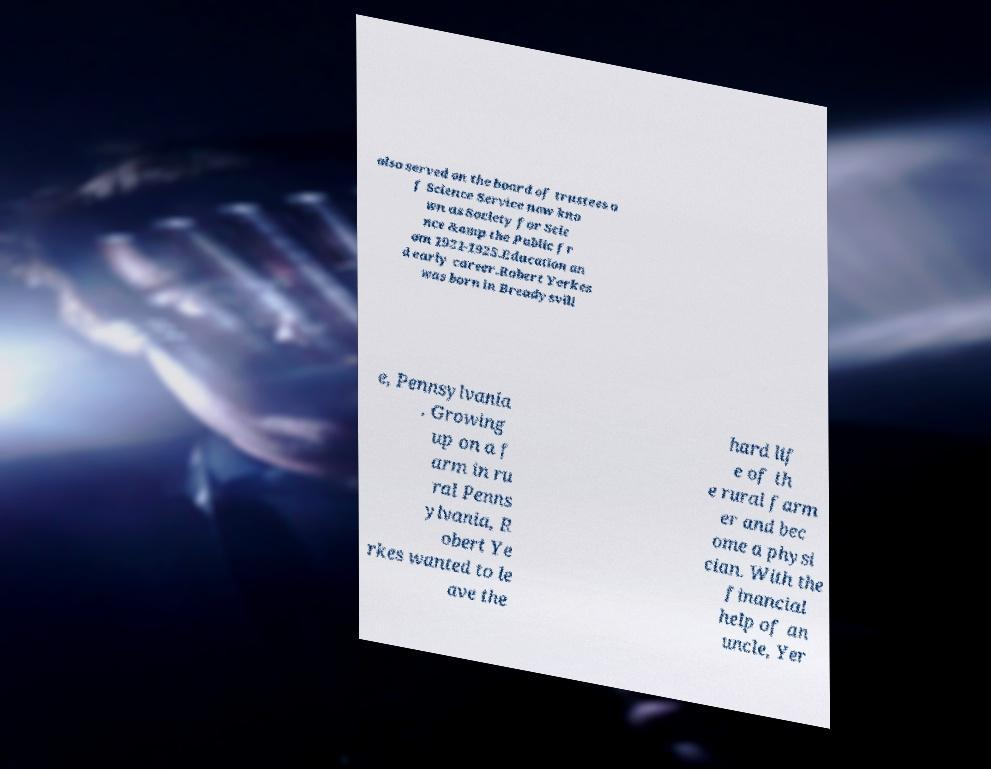Could you extract and type out the text from this image? also served on the board of trustees o f Science Service now kno wn as Society for Scie nce &amp the Public fr om 1921-1925.Education an d early career.Robert Yerkes was born in Breadysvill e, Pennsylvania . Growing up on a f arm in ru ral Penns ylvania, R obert Ye rkes wanted to le ave the hard lif e of th e rural farm er and bec ome a physi cian. With the financial help of an uncle, Yer 